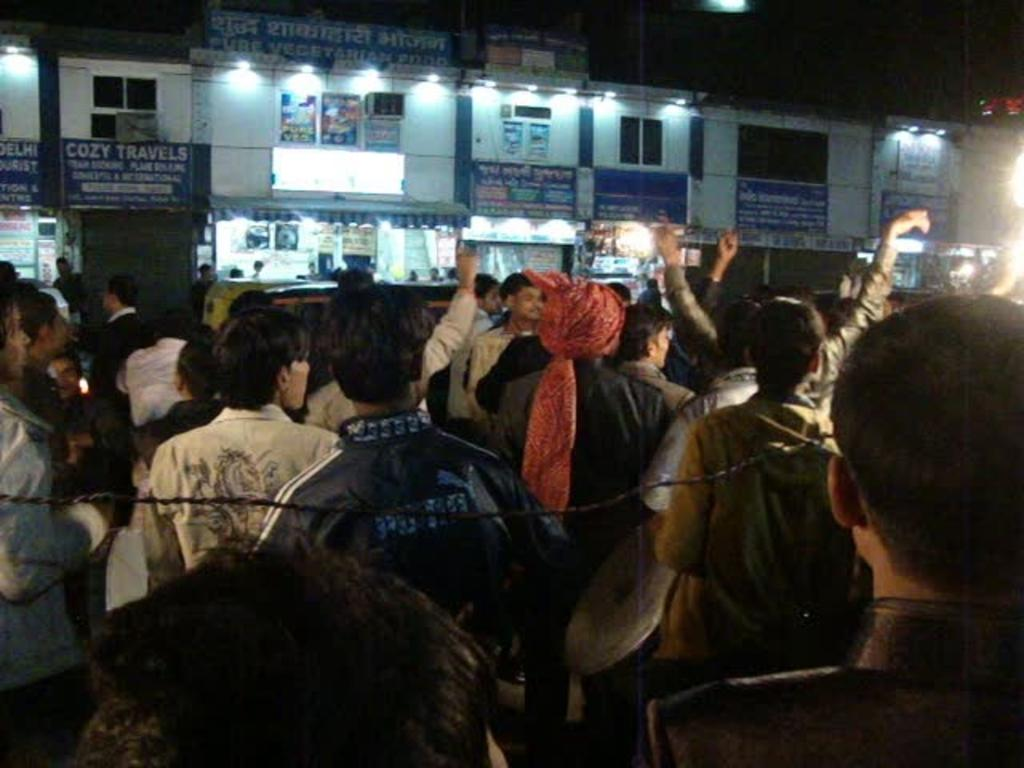What can be seen in the image? There are persons standing in the image. What is visible in the background of the image? There are buildings, boards attached to the buildings, lights, and a dark sky visible in the background. How many gloves are being worn by the persons in the image? There is no mention of gloves in the image, so it cannot be determined how many gloves are being worn. 